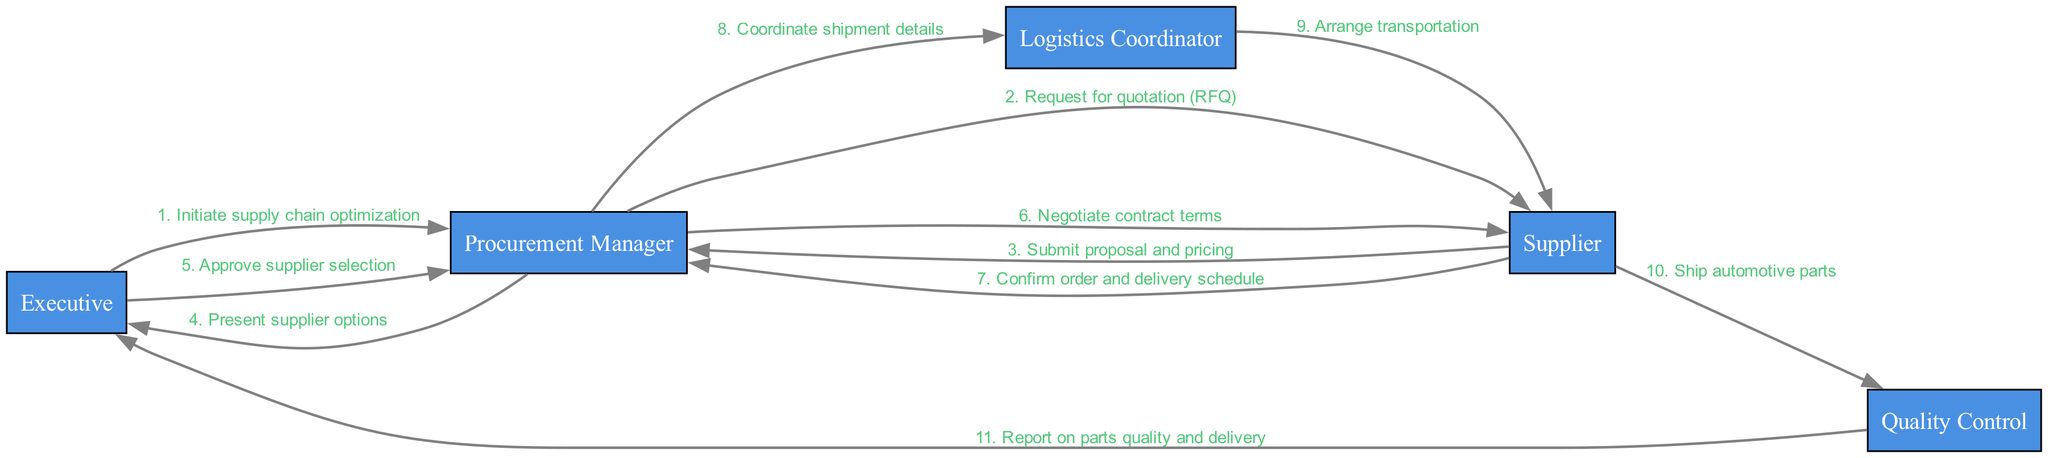What is the first action in the sequence? The first action in the sequence is initiated by the Executive, who sends the message "Initiate supply chain optimization" to the Procurement Manager.
Answer: Initiate supply chain optimization How many actors are in the diagram? There are five actors represented in the diagram: Executive, Procurement Manager, Logistics Coordinator, Supplier, and Quality Control.
Answer: 5 Who does the Logistics Coordinator communicate with? The Logistics Coordinator communicates with the Supplier to arrange transportation for the shipment of automotive parts.
Answer: Supplier What is the last message sent in the sequence? The last message sent in the sequence is "Report on parts quality and delivery" from Quality Control to the Executive.
Answer: Report on parts quality and delivery Which actor approves the supplier selection? The Executive is the actor who approves the supplier selection after reviewing the options presented by the Procurement Manager.
Answer: Executive How many messages are exchanged between the Procurement Manager and Supplier? There are four messages exchanged between the Procurement Manager and Supplier during the optimization process.
Answer: 4 What type of request does the Procurement Manager send first? The Procurement Manager sends a "Request for quotation (RFQ)" to the Supplier as the first type of request in the sequence.
Answer: Request for quotation (RFQ) Who reports to the Executive about parts quality? The Quality Control actor reports to the Executive regarding the quality and delivery of the automotive parts.
Answer: Quality Control Which step occurs immediately before negotiating contract terms? The step that occurs immediately before negotiating contract terms is the submission of the proposal and pricing by the Supplier to the Procurement Manager.
Answer: Submit proposal and pricing 